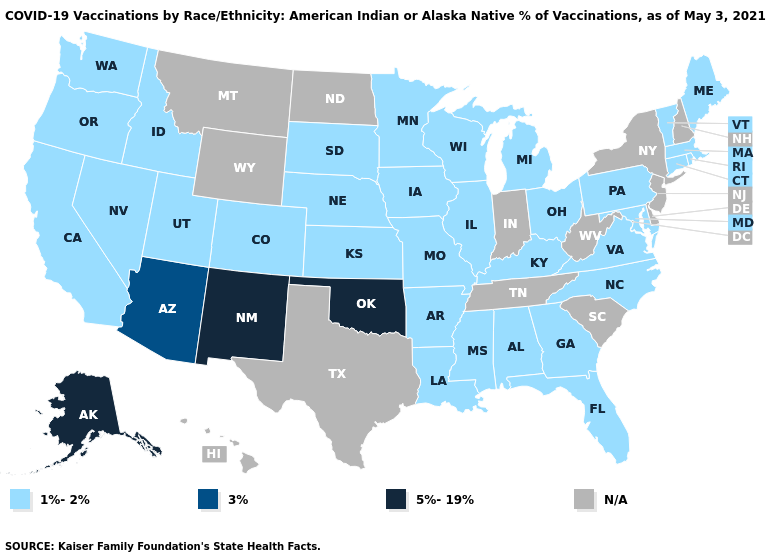Does the first symbol in the legend represent the smallest category?
Write a very short answer. Yes. What is the value of Arkansas?
Write a very short answer. 1%-2%. What is the lowest value in the MidWest?
Answer briefly. 1%-2%. Name the states that have a value in the range 1%-2%?
Write a very short answer. Alabama, Arkansas, California, Colorado, Connecticut, Florida, Georgia, Idaho, Illinois, Iowa, Kansas, Kentucky, Louisiana, Maine, Maryland, Massachusetts, Michigan, Minnesota, Mississippi, Missouri, Nebraska, Nevada, North Carolina, Ohio, Oregon, Pennsylvania, Rhode Island, South Dakota, Utah, Vermont, Virginia, Washington, Wisconsin. Among the states that border Delaware , which have the lowest value?
Quick response, please. Maryland, Pennsylvania. Name the states that have a value in the range 5%-19%?
Concise answer only. Alaska, New Mexico, Oklahoma. Does the map have missing data?
Write a very short answer. Yes. Among the states that border Oklahoma , does New Mexico have the highest value?
Write a very short answer. Yes. What is the value of Idaho?
Write a very short answer. 1%-2%. Name the states that have a value in the range 1%-2%?
Write a very short answer. Alabama, Arkansas, California, Colorado, Connecticut, Florida, Georgia, Idaho, Illinois, Iowa, Kansas, Kentucky, Louisiana, Maine, Maryland, Massachusetts, Michigan, Minnesota, Mississippi, Missouri, Nebraska, Nevada, North Carolina, Ohio, Oregon, Pennsylvania, Rhode Island, South Dakota, Utah, Vermont, Virginia, Washington, Wisconsin. What is the highest value in the USA?
Keep it brief. 5%-19%. Name the states that have a value in the range N/A?
Give a very brief answer. Delaware, Hawaii, Indiana, Montana, New Hampshire, New Jersey, New York, North Dakota, South Carolina, Tennessee, Texas, West Virginia, Wyoming. 